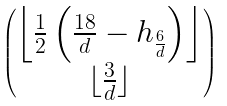<formula> <loc_0><loc_0><loc_500><loc_500>\begin{pmatrix} \left \lfloor \frac { 1 } { 2 } \left ( \frac { 1 8 } { d } - h _ { \frac { 6 } { d } } \right ) \right \rfloor \\ \lfloor \frac { 3 } { d } \rfloor \end{pmatrix}</formula> 